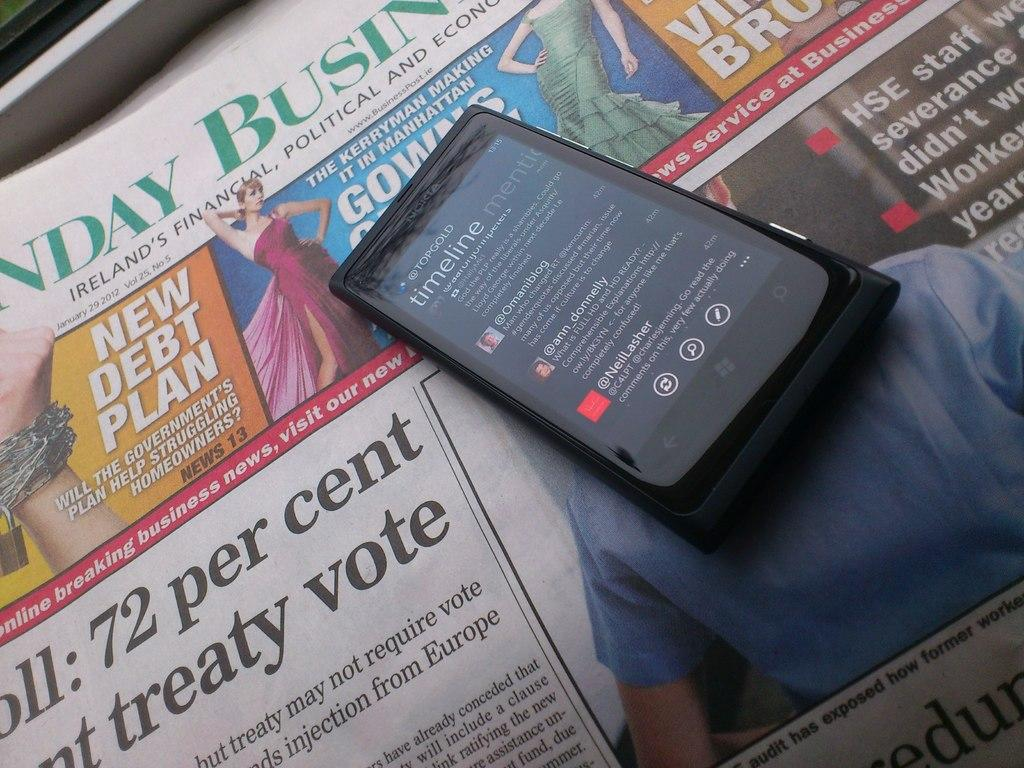<image>
Create a compact narrative representing the image presented. A newspaper that says 72 per cent and treaty vote on the front with a cell phone sitting on top of it that says timeline on the screen. 